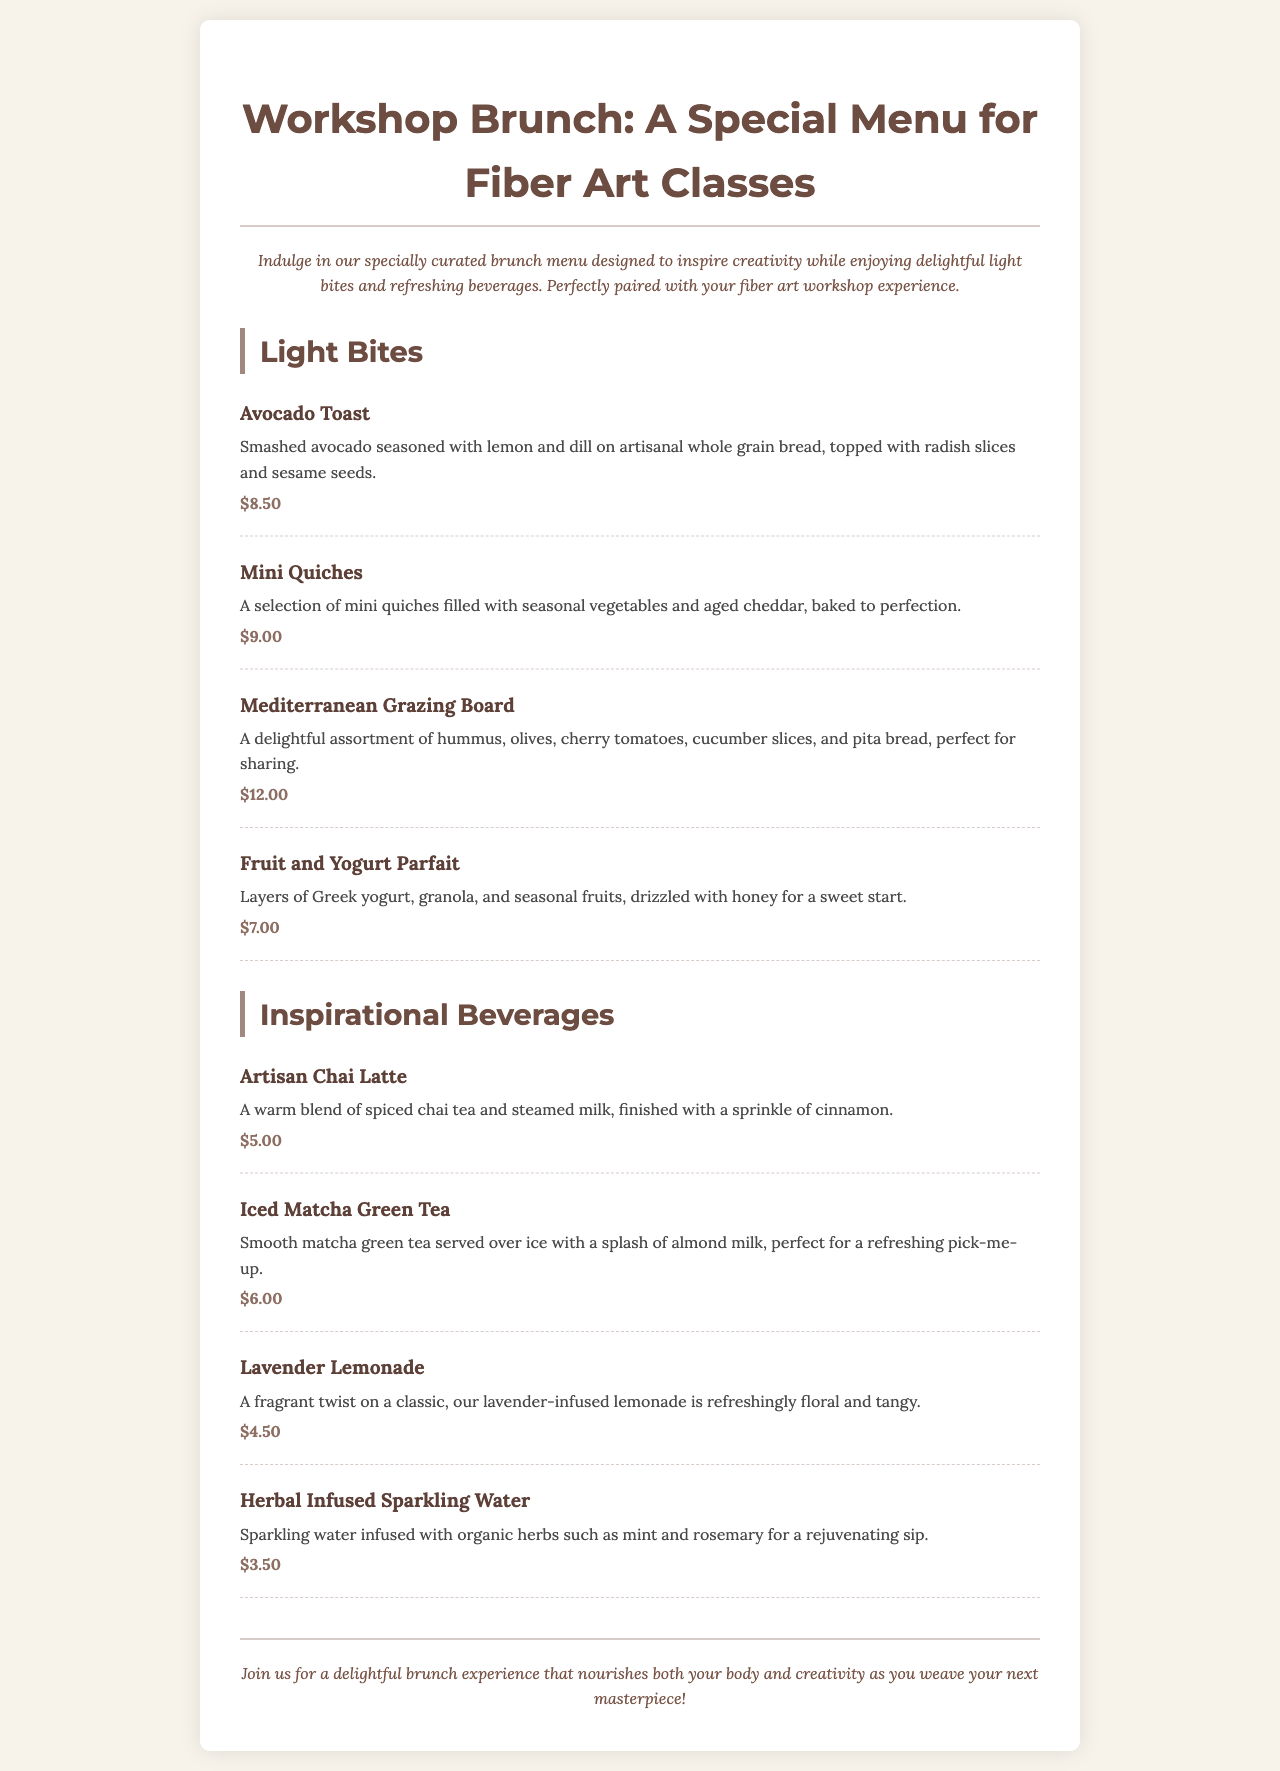what is the price of Avocado Toast? The price of Avocado Toast is listed as $8.50 in the menu.
Answer: $8.50 how many types of light bites are listed? The document lists four types of light bites under the Light Bites section.
Answer: Four what beverage has a floral twist in the menu? The beverage described as having a floral twist is Lavender Lemonade.
Answer: Lavender Lemonade what is the main ingredient in the Herbal Infused Sparkling Water? The main ingredient mentioned for Herbal Infused Sparkling Water is organic herbs such as mint and rosemary.
Answer: Organic herbs which beverage offers a refreshing pick-me-up? The Iced Matcha Green Tea is specified as perfect for a refreshing pick-me-up.
Answer: Iced Matcha Green Tea 